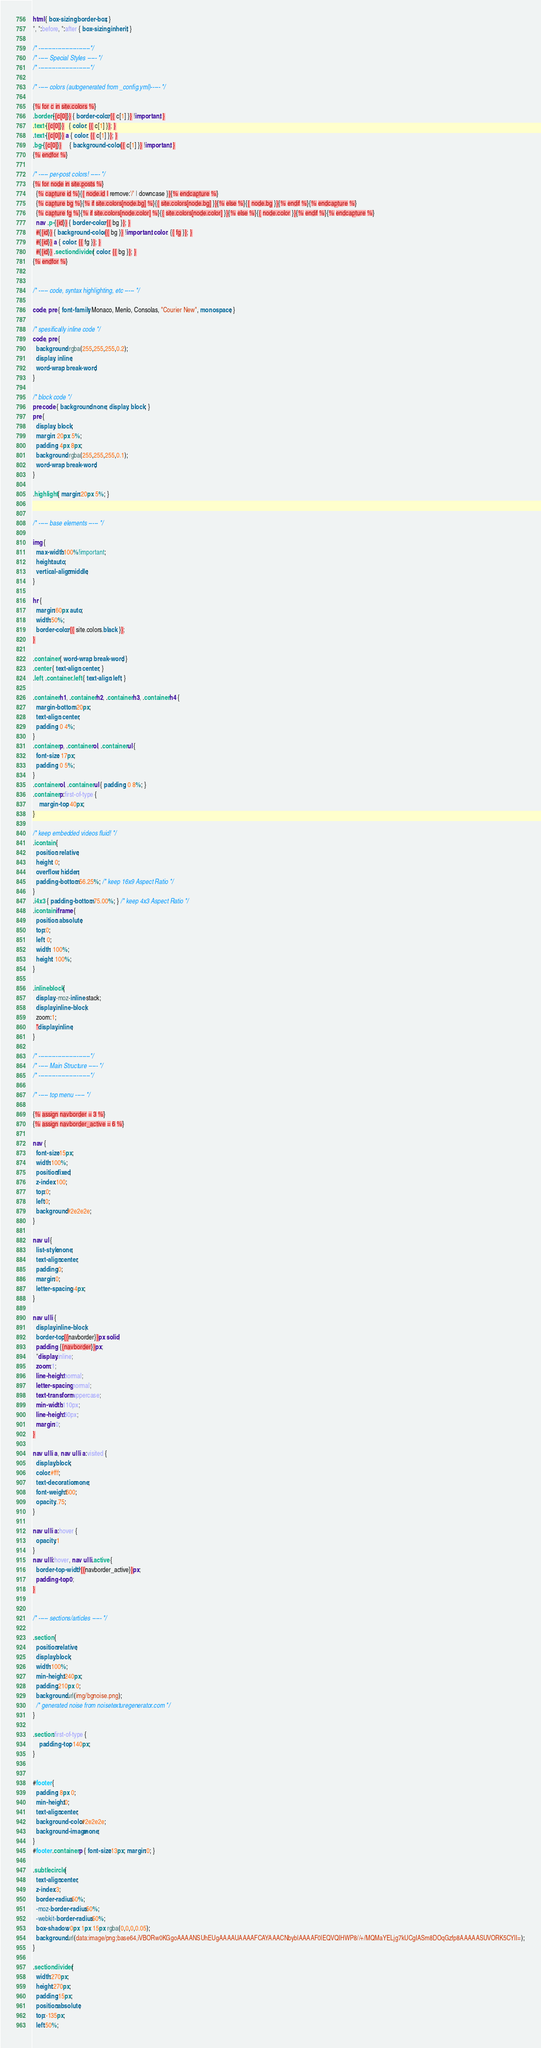Convert code to text. <code><loc_0><loc_0><loc_500><loc_500><_CSS_>html { box-sizing: border-box; }
*, *:before, *:after { box-sizing: inherit; }

/* ---------------------------*/
/* ----- Special Styles ----- */
/* ---------------------------*/

/* ----- colors (autogenerated from _config.yml)----- */

{% for c in site.colors %}
.border-{{c[0]}} { border-color: {{ c[1] }} !important; }
.text-{{c[0]}}   { color: {{ c[1] }}; }
.text-{{c[0]}} a { color: {{ c[1] }}; }
.bg-{{c[0]}}     { background-color: {{ c[1] }} !important; }
{% endfor %}

/* ----- per-post colors! ----- */
{% for node in site.posts %}
  {% capture id %}{{ node.id | remove:'/' | downcase }}{% endcapture %}
  {% capture bg %}{% if site.colors[node.bg] %}{{ site.colors[node.bg] }}{% else %}{{ node.bg }}{% endif %}{% endcapture %}
  {% capture fg %}{% if site.colors[node.color] %}{{ site.colors[node.color] }}{% else %}{{ node.color }}{% endif %}{% endcapture %}
  nav .p-{{id}} { border-color: {{ bg }}; }
  #{{id}} { background-color: {{ bg }} !important; color: {{ fg }}; }
  #{{id}} a { color: {{ fg }}; }
  #{{id}} .sectiondivider { color: {{ bg }}; }
{% endfor %}


/* ----- code, syntax highlighting, etc ----- */

code, pre { font-family: Monaco, Menlo, Consolas, "Courier New", monospace; }

/* spesifically inline code */
code, pre {
  background: rgba(255,255,255,0.2);
  display: inline;
  word-wrap: break-word;
}

/* block code */
pre code { background: none; display: block; }
pre {
  display: block;
  margin: 20px 5%;
  padding: 4px 8px;
  background: rgba(255,255,255,0.1);
  word-wrap: break-word;
}

.highlight { margin:20px 5%; }


/* ----- base elements ----- */

img {
  max-width:100%!important;
  height:auto;
  vertical-align:middle;
}

hr {
  margin:60px auto;
  width:50%;
  border-color: {{ site.colors.black }};
}

.container { word-wrap: break-word; }
.center { text-align: center; }
.left, .container .left { text-align: left; }

.container h1, .container h2, .container h3, .container h4 {
  margin-bottom: 20px;
  text-align: center;
  padding: 0 4%;
}
.container p, .container ol, .container ul {
  font-size: 17px;
  padding: 0 5%;
}
.container ol, .container ul { padding: 0 8%; }
.container p:first-of-type {
    margin-top: 40px;
}

/* keep embedded videos fluid! */
.icontain {
  position: relative;
  height: 0;
  overflow: hidden;
  padding-bottom: 56.25%; /* keep 16x9 Aspect Ratio */
}
.i4x3 { padding-bottom: 75.00%; } /* keep 4x3 Aspect Ratio */
.icontain iframe {
  position: absolute;
  top:0;
  left: 0;
  width: 100%;
  height: 100%;
}

.inlineblock {
  display:-moz-inline-stack;
  display:inline-block;
  zoom:1;
  *display:inline;
}

/* ---------------------------*/
/* ----- Main Structure ----- */
/* ---------------------------*/

/* ----- top menu ----- */

{% assign navborder = 3 %}
{% assign navborder_active = 6 %}

nav {
  font-size:15px;
  width:100%;
  position:fixed;
  z-index:100;
  top:0;
  left:0;
  background:#2e2e2e;
}

nav ul {
  list-style:none;
  text-align:center;
  padding:0;
  margin:0;
  letter-spacing:-4px;
}

nav ul li {
  display:inline-block;
  border-top:{{navborder}}px solid;
  padding: {{navborder}}px;
  *display:inline;
  zoom:1;
  line-height:normal;
  letter-spacing:normal;
  text-transform:uppercase;
  min-width:110px;
  line-height:60px;
  margin:0;
}

nav ul li a, nav ul li a:visited {
  display:block;
  color:#fff;
  text-decoration:none;
  font-weight:600;
  opacity:.75;
}

nav ul li a:hover {
  opacity:1
}
nav ul li:hover, nav ul li.active {
  border-top-width: {{navborder_active}}px;
  padding-top: 0;
}


/* ----- sections/articles ----- */

.section {
  position:relative;
  display:block;
  width:100%;
  min-height:240px;
  padding:210px 0;
  background:url(img/bgnoise.png);
  /* generated noise from noisetexturegenerator.com */
}

.section:first-of-type {
    padding-top: 140px;
}


#footer {
  padding: 8px 0;
  min-height:0;
  text-align:center;
  background-color:#2e2e2e;
  background-image:none;
}
#footer .container p { font-size:13px; margin:0; }

.subtlecircle {
  text-align:center;
  z-index:3;
  border-radius:50%;
  -moz-border-radius:50%;
  -webkit-border-radius:50%;
  box-shadow: 0px 1px 15px rgba(0,0,0,0.05);
  background:url(data:image/png;base64,iVBORw0KGgoAAAANSUhEUgAAAAUAAAAFCAYAAACNbyblAAAAF0lEQVQIHWP8//+/MQMaYELjg7kUCgIASm8DOqGzfp8AAAAASUVORK5CYII=);
}

.sectiondivider {
  width:270px;
  height:270px;
  padding:15px;
  position:absolute;
  top:-135px;
  left:50%;</code> 